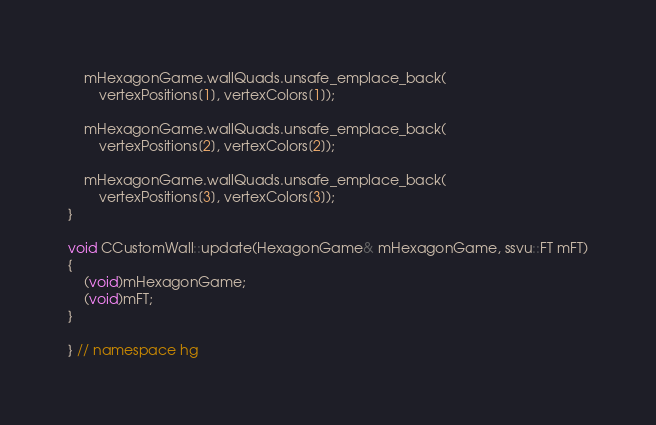Convert code to text. <code><loc_0><loc_0><loc_500><loc_500><_C++_>    mHexagonGame.wallQuads.unsafe_emplace_back(
        vertexPositions[1], vertexColors[1]);

    mHexagonGame.wallQuads.unsafe_emplace_back(
        vertexPositions[2], vertexColors[2]);

    mHexagonGame.wallQuads.unsafe_emplace_back(
        vertexPositions[3], vertexColors[3]);
}

void CCustomWall::update(HexagonGame& mHexagonGame, ssvu::FT mFT)
{
    (void)mHexagonGame;
    (void)mFT;
}

} // namespace hg
</code> 